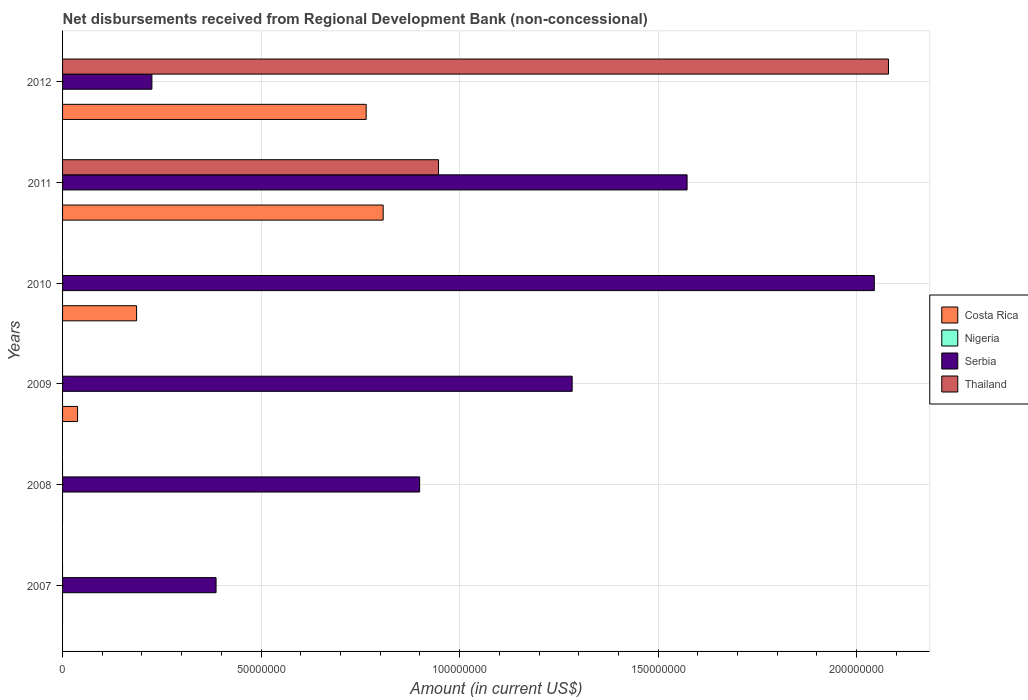Are the number of bars on each tick of the Y-axis equal?
Provide a succinct answer. No. How many bars are there on the 2nd tick from the bottom?
Offer a terse response. 1. What is the amount of disbursements received from Regional Development Bank in Serbia in 2008?
Provide a succinct answer. 8.99e+07. Across all years, what is the maximum amount of disbursements received from Regional Development Bank in Costa Rica?
Keep it short and to the point. 8.07e+07. In which year was the amount of disbursements received from Regional Development Bank in Costa Rica maximum?
Provide a succinct answer. 2011. What is the difference between the amount of disbursements received from Regional Development Bank in Thailand in 2011 and that in 2012?
Keep it short and to the point. -1.13e+08. What is the difference between the amount of disbursements received from Regional Development Bank in Nigeria in 2010 and the amount of disbursements received from Regional Development Bank in Costa Rica in 2012?
Offer a very short reply. -7.65e+07. What is the average amount of disbursements received from Regional Development Bank in Thailand per year?
Make the answer very short. 5.04e+07. In the year 2012, what is the difference between the amount of disbursements received from Regional Development Bank in Serbia and amount of disbursements received from Regional Development Bank in Costa Rica?
Provide a short and direct response. -5.40e+07. In how many years, is the amount of disbursements received from Regional Development Bank in Thailand greater than 100000000 US$?
Give a very brief answer. 1. What is the ratio of the amount of disbursements received from Regional Development Bank in Serbia in 2007 to that in 2012?
Provide a short and direct response. 1.72. Is the amount of disbursements received from Regional Development Bank in Serbia in 2008 less than that in 2011?
Your response must be concise. Yes. Is the difference between the amount of disbursements received from Regional Development Bank in Serbia in 2010 and 2012 greater than the difference between the amount of disbursements received from Regional Development Bank in Costa Rica in 2010 and 2012?
Your response must be concise. Yes. What is the difference between the highest and the second highest amount of disbursements received from Regional Development Bank in Serbia?
Keep it short and to the point. 4.72e+07. What is the difference between the highest and the lowest amount of disbursements received from Regional Development Bank in Serbia?
Provide a short and direct response. 1.82e+08. In how many years, is the amount of disbursements received from Regional Development Bank in Thailand greater than the average amount of disbursements received from Regional Development Bank in Thailand taken over all years?
Your answer should be compact. 2. Is the sum of the amount of disbursements received from Regional Development Bank in Serbia in 2008 and 2010 greater than the maximum amount of disbursements received from Regional Development Bank in Thailand across all years?
Your answer should be very brief. Yes. Is it the case that in every year, the sum of the amount of disbursements received from Regional Development Bank in Serbia and amount of disbursements received from Regional Development Bank in Thailand is greater than the sum of amount of disbursements received from Regional Development Bank in Costa Rica and amount of disbursements received from Regional Development Bank in Nigeria?
Your answer should be very brief. No. How many years are there in the graph?
Keep it short and to the point. 6. Are the values on the major ticks of X-axis written in scientific E-notation?
Your answer should be compact. No. Does the graph contain any zero values?
Your answer should be very brief. Yes. What is the title of the graph?
Your answer should be compact. Net disbursements received from Regional Development Bank (non-concessional). What is the label or title of the X-axis?
Offer a very short reply. Amount (in current US$). What is the Amount (in current US$) in Nigeria in 2007?
Give a very brief answer. 0. What is the Amount (in current US$) in Serbia in 2007?
Keep it short and to the point. 3.87e+07. What is the Amount (in current US$) of Thailand in 2007?
Your response must be concise. 0. What is the Amount (in current US$) of Serbia in 2008?
Your answer should be compact. 8.99e+07. What is the Amount (in current US$) in Thailand in 2008?
Provide a succinct answer. 0. What is the Amount (in current US$) in Costa Rica in 2009?
Offer a terse response. 3.78e+06. What is the Amount (in current US$) in Nigeria in 2009?
Offer a terse response. 0. What is the Amount (in current US$) of Serbia in 2009?
Your answer should be compact. 1.28e+08. What is the Amount (in current US$) in Costa Rica in 2010?
Keep it short and to the point. 1.86e+07. What is the Amount (in current US$) in Nigeria in 2010?
Your answer should be compact. 0. What is the Amount (in current US$) in Serbia in 2010?
Keep it short and to the point. 2.04e+08. What is the Amount (in current US$) in Costa Rica in 2011?
Provide a succinct answer. 8.07e+07. What is the Amount (in current US$) of Nigeria in 2011?
Give a very brief answer. 0. What is the Amount (in current US$) in Serbia in 2011?
Your answer should be very brief. 1.57e+08. What is the Amount (in current US$) of Thailand in 2011?
Ensure brevity in your answer.  9.47e+07. What is the Amount (in current US$) in Costa Rica in 2012?
Offer a terse response. 7.65e+07. What is the Amount (in current US$) in Nigeria in 2012?
Your answer should be very brief. 0. What is the Amount (in current US$) of Serbia in 2012?
Your answer should be compact. 2.25e+07. What is the Amount (in current US$) in Thailand in 2012?
Provide a short and direct response. 2.08e+08. Across all years, what is the maximum Amount (in current US$) in Costa Rica?
Offer a terse response. 8.07e+07. Across all years, what is the maximum Amount (in current US$) in Serbia?
Your response must be concise. 2.04e+08. Across all years, what is the maximum Amount (in current US$) of Thailand?
Provide a short and direct response. 2.08e+08. Across all years, what is the minimum Amount (in current US$) in Costa Rica?
Make the answer very short. 0. Across all years, what is the minimum Amount (in current US$) in Serbia?
Offer a very short reply. 2.25e+07. Across all years, what is the minimum Amount (in current US$) in Thailand?
Give a very brief answer. 0. What is the total Amount (in current US$) of Costa Rica in the graph?
Your response must be concise. 1.80e+08. What is the total Amount (in current US$) of Nigeria in the graph?
Your answer should be very brief. 0. What is the total Amount (in current US$) in Serbia in the graph?
Make the answer very short. 6.41e+08. What is the total Amount (in current US$) in Thailand in the graph?
Make the answer very short. 3.03e+08. What is the difference between the Amount (in current US$) in Serbia in 2007 and that in 2008?
Your answer should be compact. -5.13e+07. What is the difference between the Amount (in current US$) of Serbia in 2007 and that in 2009?
Offer a terse response. -8.97e+07. What is the difference between the Amount (in current US$) of Serbia in 2007 and that in 2010?
Keep it short and to the point. -1.66e+08. What is the difference between the Amount (in current US$) in Serbia in 2007 and that in 2011?
Provide a succinct answer. -1.19e+08. What is the difference between the Amount (in current US$) in Serbia in 2007 and that in 2012?
Make the answer very short. 1.62e+07. What is the difference between the Amount (in current US$) of Serbia in 2008 and that in 2009?
Offer a terse response. -3.84e+07. What is the difference between the Amount (in current US$) in Serbia in 2008 and that in 2010?
Offer a terse response. -1.15e+08. What is the difference between the Amount (in current US$) of Serbia in 2008 and that in 2011?
Offer a very short reply. -6.74e+07. What is the difference between the Amount (in current US$) of Serbia in 2008 and that in 2012?
Keep it short and to the point. 6.74e+07. What is the difference between the Amount (in current US$) in Costa Rica in 2009 and that in 2010?
Offer a very short reply. -1.49e+07. What is the difference between the Amount (in current US$) in Serbia in 2009 and that in 2010?
Your answer should be very brief. -7.61e+07. What is the difference between the Amount (in current US$) of Costa Rica in 2009 and that in 2011?
Keep it short and to the point. -7.70e+07. What is the difference between the Amount (in current US$) of Serbia in 2009 and that in 2011?
Your response must be concise. -2.89e+07. What is the difference between the Amount (in current US$) of Costa Rica in 2009 and that in 2012?
Give a very brief answer. -7.27e+07. What is the difference between the Amount (in current US$) in Serbia in 2009 and that in 2012?
Offer a very short reply. 1.06e+08. What is the difference between the Amount (in current US$) of Costa Rica in 2010 and that in 2011?
Offer a terse response. -6.21e+07. What is the difference between the Amount (in current US$) in Serbia in 2010 and that in 2011?
Ensure brevity in your answer.  4.72e+07. What is the difference between the Amount (in current US$) of Costa Rica in 2010 and that in 2012?
Provide a succinct answer. -5.78e+07. What is the difference between the Amount (in current US$) in Serbia in 2010 and that in 2012?
Your answer should be very brief. 1.82e+08. What is the difference between the Amount (in current US$) in Costa Rica in 2011 and that in 2012?
Give a very brief answer. 4.28e+06. What is the difference between the Amount (in current US$) of Serbia in 2011 and that in 2012?
Your answer should be very brief. 1.35e+08. What is the difference between the Amount (in current US$) in Thailand in 2011 and that in 2012?
Provide a succinct answer. -1.13e+08. What is the difference between the Amount (in current US$) in Serbia in 2007 and the Amount (in current US$) in Thailand in 2011?
Offer a very short reply. -5.60e+07. What is the difference between the Amount (in current US$) in Serbia in 2007 and the Amount (in current US$) in Thailand in 2012?
Your answer should be compact. -1.69e+08. What is the difference between the Amount (in current US$) of Serbia in 2008 and the Amount (in current US$) of Thailand in 2011?
Offer a very short reply. -4.76e+06. What is the difference between the Amount (in current US$) in Serbia in 2008 and the Amount (in current US$) in Thailand in 2012?
Keep it short and to the point. -1.18e+08. What is the difference between the Amount (in current US$) in Costa Rica in 2009 and the Amount (in current US$) in Serbia in 2010?
Keep it short and to the point. -2.01e+08. What is the difference between the Amount (in current US$) in Costa Rica in 2009 and the Amount (in current US$) in Serbia in 2011?
Give a very brief answer. -1.54e+08. What is the difference between the Amount (in current US$) in Costa Rica in 2009 and the Amount (in current US$) in Thailand in 2011?
Your answer should be compact. -9.09e+07. What is the difference between the Amount (in current US$) in Serbia in 2009 and the Amount (in current US$) in Thailand in 2011?
Provide a succinct answer. 3.37e+07. What is the difference between the Amount (in current US$) of Costa Rica in 2009 and the Amount (in current US$) of Serbia in 2012?
Your answer should be compact. -1.87e+07. What is the difference between the Amount (in current US$) of Costa Rica in 2009 and the Amount (in current US$) of Thailand in 2012?
Keep it short and to the point. -2.04e+08. What is the difference between the Amount (in current US$) of Serbia in 2009 and the Amount (in current US$) of Thailand in 2012?
Offer a terse response. -7.97e+07. What is the difference between the Amount (in current US$) of Costa Rica in 2010 and the Amount (in current US$) of Serbia in 2011?
Keep it short and to the point. -1.39e+08. What is the difference between the Amount (in current US$) of Costa Rica in 2010 and the Amount (in current US$) of Thailand in 2011?
Ensure brevity in your answer.  -7.60e+07. What is the difference between the Amount (in current US$) of Serbia in 2010 and the Amount (in current US$) of Thailand in 2011?
Provide a short and direct response. 1.10e+08. What is the difference between the Amount (in current US$) in Costa Rica in 2010 and the Amount (in current US$) in Serbia in 2012?
Make the answer very short. -3.86e+06. What is the difference between the Amount (in current US$) of Costa Rica in 2010 and the Amount (in current US$) of Thailand in 2012?
Ensure brevity in your answer.  -1.89e+08. What is the difference between the Amount (in current US$) of Serbia in 2010 and the Amount (in current US$) of Thailand in 2012?
Offer a terse response. -3.56e+06. What is the difference between the Amount (in current US$) in Costa Rica in 2011 and the Amount (in current US$) in Serbia in 2012?
Give a very brief answer. 5.82e+07. What is the difference between the Amount (in current US$) of Costa Rica in 2011 and the Amount (in current US$) of Thailand in 2012?
Offer a terse response. -1.27e+08. What is the difference between the Amount (in current US$) in Serbia in 2011 and the Amount (in current US$) in Thailand in 2012?
Provide a short and direct response. -5.07e+07. What is the average Amount (in current US$) in Costa Rica per year?
Your answer should be very brief. 2.99e+07. What is the average Amount (in current US$) of Serbia per year?
Offer a terse response. 1.07e+08. What is the average Amount (in current US$) in Thailand per year?
Offer a very short reply. 5.04e+07. In the year 2009, what is the difference between the Amount (in current US$) in Costa Rica and Amount (in current US$) in Serbia?
Ensure brevity in your answer.  -1.25e+08. In the year 2010, what is the difference between the Amount (in current US$) in Costa Rica and Amount (in current US$) in Serbia?
Provide a short and direct response. -1.86e+08. In the year 2011, what is the difference between the Amount (in current US$) of Costa Rica and Amount (in current US$) of Serbia?
Offer a very short reply. -7.65e+07. In the year 2011, what is the difference between the Amount (in current US$) in Costa Rica and Amount (in current US$) in Thailand?
Your answer should be very brief. -1.39e+07. In the year 2011, what is the difference between the Amount (in current US$) of Serbia and Amount (in current US$) of Thailand?
Offer a very short reply. 6.26e+07. In the year 2012, what is the difference between the Amount (in current US$) of Costa Rica and Amount (in current US$) of Serbia?
Give a very brief answer. 5.40e+07. In the year 2012, what is the difference between the Amount (in current US$) in Costa Rica and Amount (in current US$) in Thailand?
Give a very brief answer. -1.32e+08. In the year 2012, what is the difference between the Amount (in current US$) of Serbia and Amount (in current US$) of Thailand?
Ensure brevity in your answer.  -1.85e+08. What is the ratio of the Amount (in current US$) of Serbia in 2007 to that in 2008?
Provide a succinct answer. 0.43. What is the ratio of the Amount (in current US$) in Serbia in 2007 to that in 2009?
Give a very brief answer. 0.3. What is the ratio of the Amount (in current US$) of Serbia in 2007 to that in 2010?
Keep it short and to the point. 0.19. What is the ratio of the Amount (in current US$) of Serbia in 2007 to that in 2011?
Keep it short and to the point. 0.25. What is the ratio of the Amount (in current US$) of Serbia in 2007 to that in 2012?
Offer a terse response. 1.72. What is the ratio of the Amount (in current US$) in Serbia in 2008 to that in 2009?
Provide a short and direct response. 0.7. What is the ratio of the Amount (in current US$) in Serbia in 2008 to that in 2010?
Your response must be concise. 0.44. What is the ratio of the Amount (in current US$) of Serbia in 2008 to that in 2011?
Keep it short and to the point. 0.57. What is the ratio of the Amount (in current US$) in Serbia in 2008 to that in 2012?
Your answer should be very brief. 4. What is the ratio of the Amount (in current US$) of Costa Rica in 2009 to that in 2010?
Keep it short and to the point. 0.2. What is the ratio of the Amount (in current US$) of Serbia in 2009 to that in 2010?
Provide a succinct answer. 0.63. What is the ratio of the Amount (in current US$) of Costa Rica in 2009 to that in 2011?
Provide a succinct answer. 0.05. What is the ratio of the Amount (in current US$) of Serbia in 2009 to that in 2011?
Keep it short and to the point. 0.82. What is the ratio of the Amount (in current US$) in Costa Rica in 2009 to that in 2012?
Ensure brevity in your answer.  0.05. What is the ratio of the Amount (in current US$) of Serbia in 2009 to that in 2012?
Provide a succinct answer. 5.7. What is the ratio of the Amount (in current US$) of Costa Rica in 2010 to that in 2011?
Ensure brevity in your answer.  0.23. What is the ratio of the Amount (in current US$) of Serbia in 2010 to that in 2011?
Make the answer very short. 1.3. What is the ratio of the Amount (in current US$) in Costa Rica in 2010 to that in 2012?
Offer a very short reply. 0.24. What is the ratio of the Amount (in current US$) of Serbia in 2010 to that in 2012?
Offer a very short reply. 9.09. What is the ratio of the Amount (in current US$) of Costa Rica in 2011 to that in 2012?
Offer a terse response. 1.06. What is the ratio of the Amount (in current US$) of Serbia in 2011 to that in 2012?
Give a very brief answer. 6.99. What is the ratio of the Amount (in current US$) of Thailand in 2011 to that in 2012?
Make the answer very short. 0.46. What is the difference between the highest and the second highest Amount (in current US$) of Costa Rica?
Provide a short and direct response. 4.28e+06. What is the difference between the highest and the second highest Amount (in current US$) in Serbia?
Your answer should be compact. 4.72e+07. What is the difference between the highest and the lowest Amount (in current US$) of Costa Rica?
Provide a short and direct response. 8.07e+07. What is the difference between the highest and the lowest Amount (in current US$) of Serbia?
Keep it short and to the point. 1.82e+08. What is the difference between the highest and the lowest Amount (in current US$) in Thailand?
Your response must be concise. 2.08e+08. 